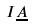<formula> <loc_0><loc_0><loc_500><loc_500>I \underline { A }</formula> 